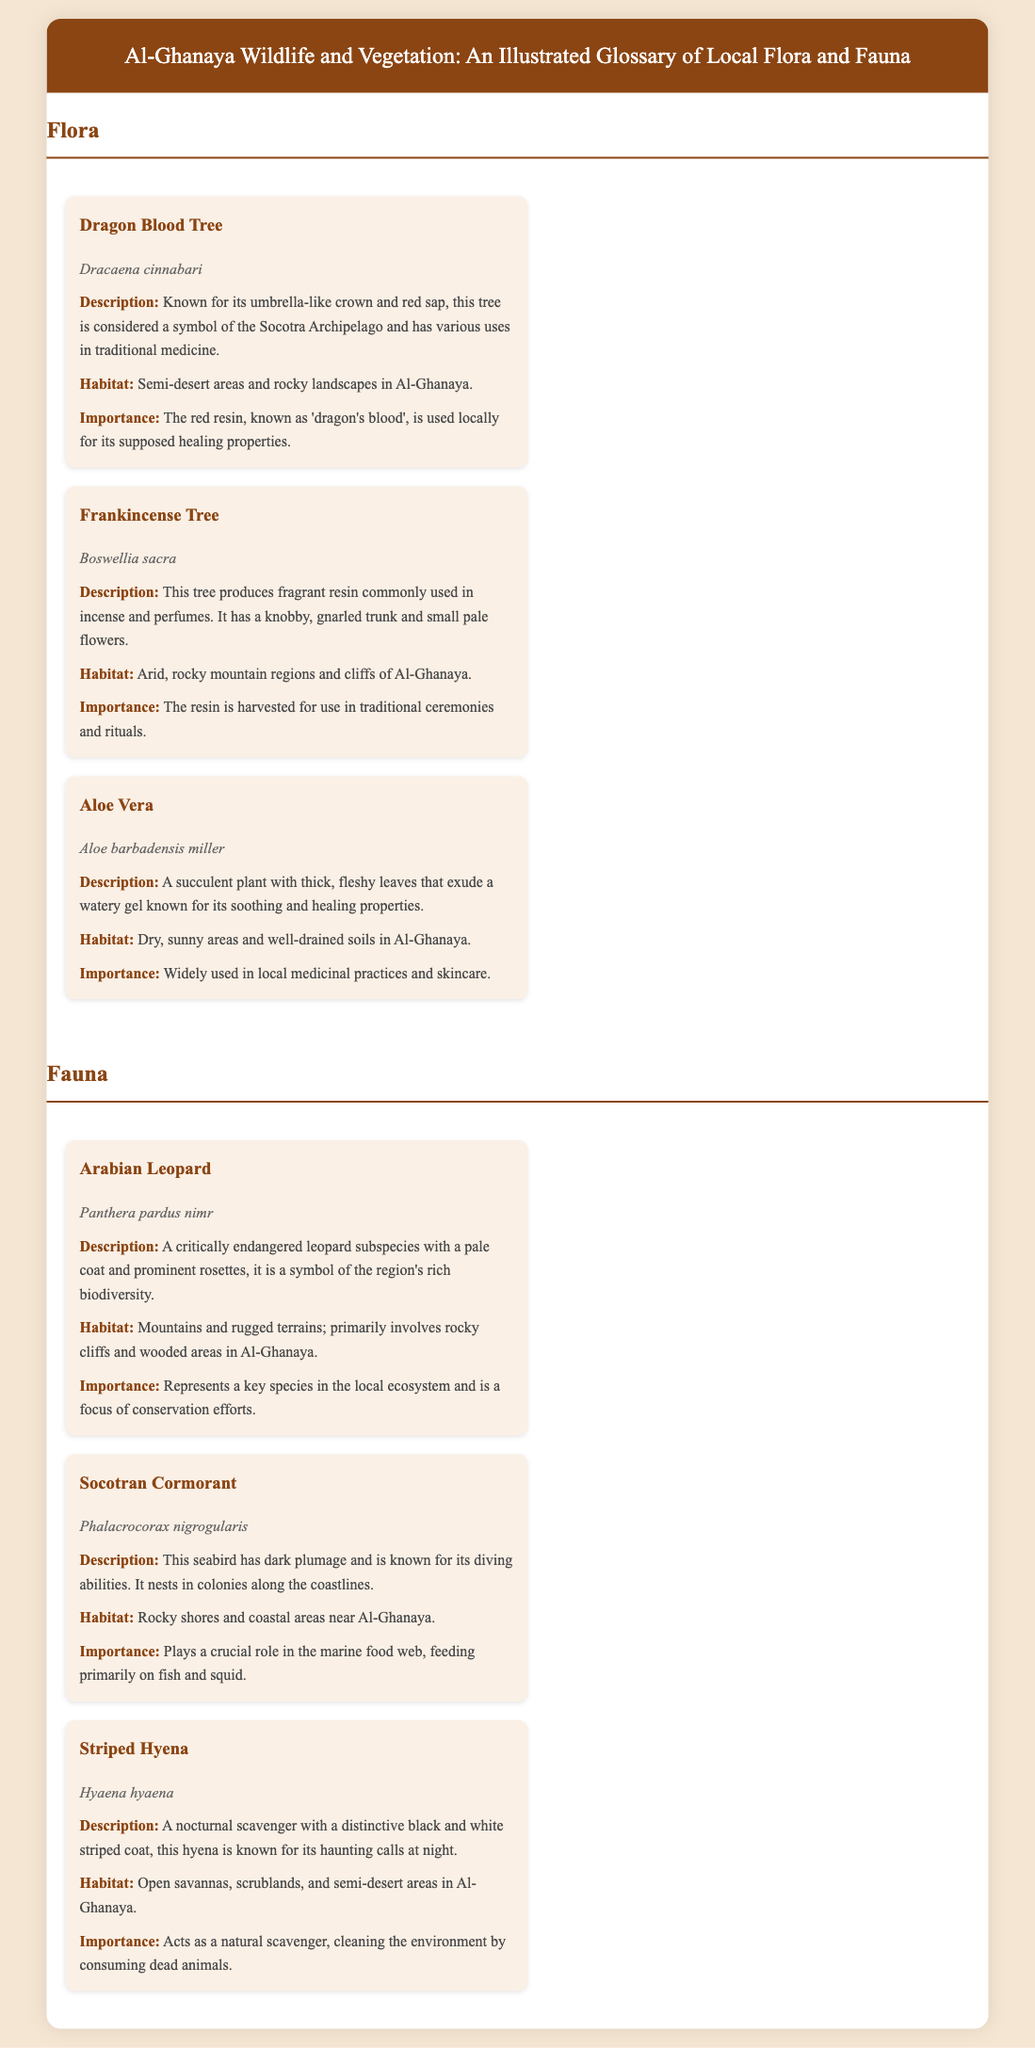What is the scientific name of the Dragon Blood Tree? The scientific name is located in the entry for the Dragon Blood Tree, which is Dracaena cinnabari.
Answer: Dracaena cinnabari What type of habitat does the Arabian Leopard prefer? The habitat information for the Arabian Leopard specifies that it prefers mountains and rugged terrains, primarily involving rocky cliffs and wooded areas in Al-Ghanaya.
Answer: Mountains and rugged terrains What is the importance of Aloe Vera in local practices? The importance section for Aloe Vera states that it is widely used in local medicinal practices and skincare.
Answer: Local medicinal practices and skincare How is the resin of the Frankincense Tree used? The importance of the Frankincense Tree describes the resin as being harvested for use in traditional ceremonies and rituals.
Answer: Traditional ceremonies and rituals What common feature identifies the Striped Hyena? The description of the Striped Hyena mentions its distinctive black and white striped coat.
Answer: Black and white striped coat Which flora species is considered a symbol of the Socotra Archipelago? The information about the Dragon Blood Tree indicates that it is considered a symbol of the Socotra Archipelago.
Answer: Dragon Blood Tree What is the habitat of the Socotran Cormorant? The habitat section for the Socotran Cormorant notes that it inhabits rocky shores and coastal areas near Al-Ghanaya.
Answer: Rocky shores and coastal areas What floral species exudes a watery gel? The description of Aloe Vera specifies that it exudes a watery gel known for its soothing and healing properties.
Answer: Aloe Vera What is the primary diet of the Socotran Cormorant? The importance section indicates that the Socotran Cormorant feeds primarily on fish and squid.
Answer: Fish and squid 